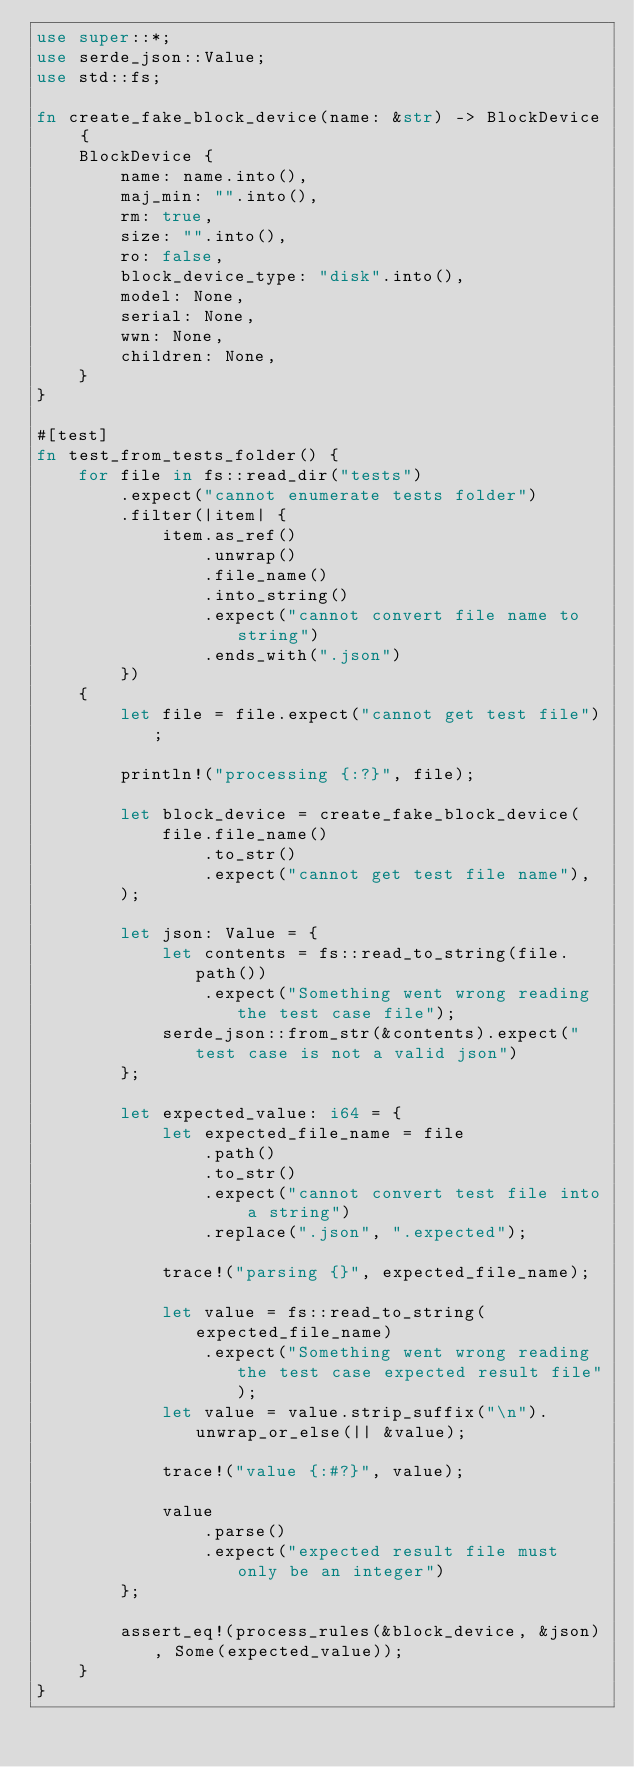Convert code to text. <code><loc_0><loc_0><loc_500><loc_500><_Rust_>use super::*;
use serde_json::Value;
use std::fs;

fn create_fake_block_device(name: &str) -> BlockDevice {
    BlockDevice {
        name: name.into(),
        maj_min: "".into(),
        rm: true,
        size: "".into(),
        ro: false,
        block_device_type: "disk".into(),
        model: None,
        serial: None,
        wwn: None,
        children: None,
    }
}

#[test]
fn test_from_tests_folder() {
    for file in fs::read_dir("tests")
        .expect("cannot enumerate tests folder")
        .filter(|item| {
            item.as_ref()
                .unwrap()
                .file_name()
                .into_string()
                .expect("cannot convert file name to string")
                .ends_with(".json")
        })
    {
        let file = file.expect("cannot get test file");

        println!("processing {:?}", file);

        let block_device = create_fake_block_device(
            file.file_name()
                .to_str()
                .expect("cannot get test file name"),
        );

        let json: Value = {
            let contents = fs::read_to_string(file.path())
                .expect("Something went wrong reading the test case file");
            serde_json::from_str(&contents).expect("test case is not a valid json")
        };

        let expected_value: i64 = {
            let expected_file_name = file
                .path()
                .to_str()
                .expect("cannot convert test file into a string")
                .replace(".json", ".expected");

            trace!("parsing {}", expected_file_name);

            let value = fs::read_to_string(expected_file_name)
                .expect("Something went wrong reading the test case expected result file");
            let value = value.strip_suffix("\n").unwrap_or_else(|| &value);

            trace!("value {:#?}", value);

            value
                .parse()
                .expect("expected result file must only be an integer")
        };

        assert_eq!(process_rules(&block_device, &json), Some(expected_value));
    }
}
</code> 